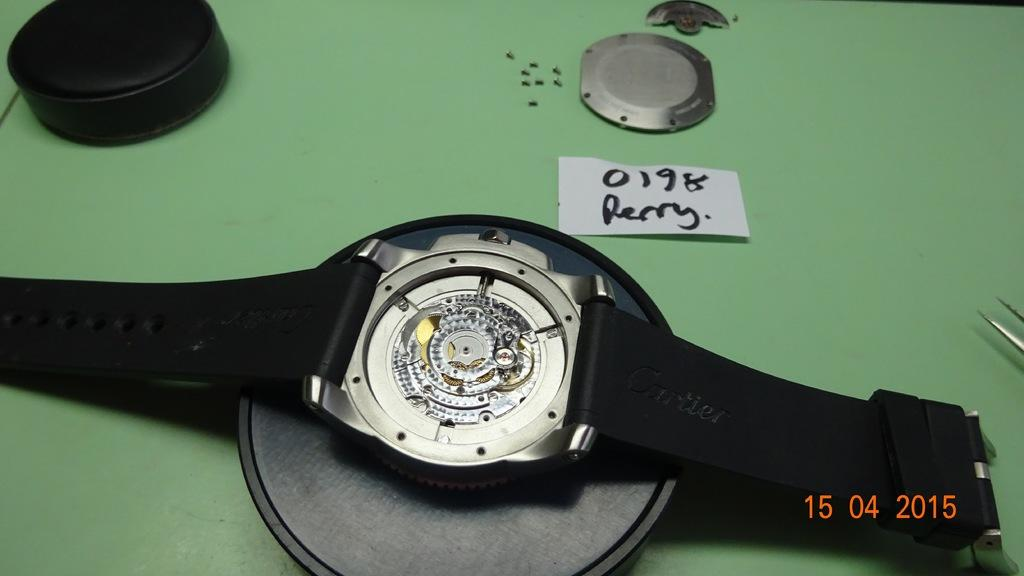<image>
Offer a succinct explanation of the picture presented. Watch being fixed with a small piece of paper that says "0198 Rerry" on it. 